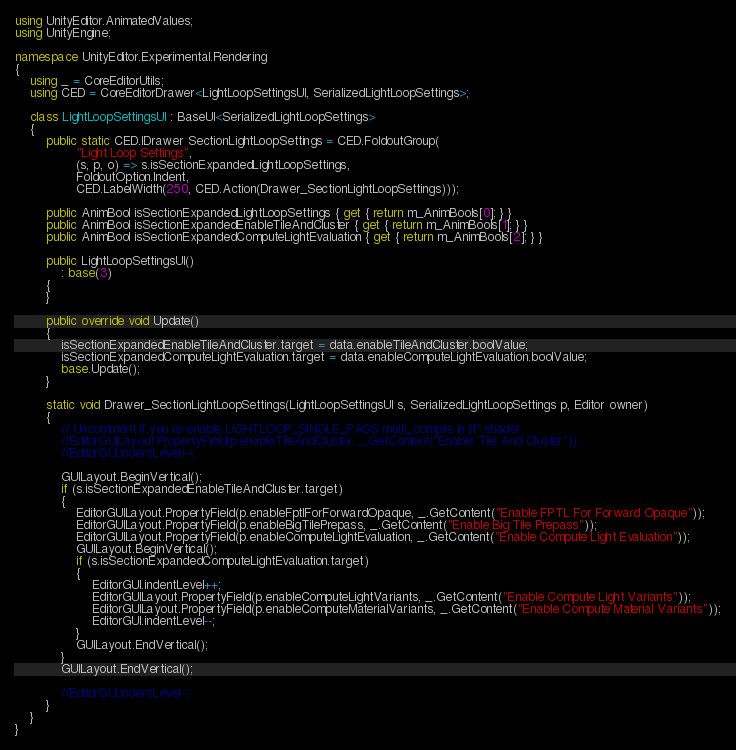Convert code to text. <code><loc_0><loc_0><loc_500><loc_500><_C#_>using UnityEditor.AnimatedValues;
using UnityEngine;

namespace UnityEditor.Experimental.Rendering
{
    using _ = CoreEditorUtils;
    using CED = CoreEditorDrawer<LightLoopSettingsUI, SerializedLightLoopSettings>;

    class LightLoopSettingsUI : BaseUI<SerializedLightLoopSettings>
    {
        public static CED.IDrawer SectionLightLoopSettings = CED.FoldoutGroup(
                "Light Loop Settings",
                (s, p, o) => s.isSectionExpandedLightLoopSettings,
                FoldoutOption.Indent,
                CED.LabelWidth(250, CED.Action(Drawer_SectionLightLoopSettings)));

        public AnimBool isSectionExpandedLightLoopSettings { get { return m_AnimBools[0]; } }
        public AnimBool isSectionExpandedEnableTileAndCluster { get { return m_AnimBools[1]; } }
        public AnimBool isSectionExpandedComputeLightEvaluation { get { return m_AnimBools[2]; } }

        public LightLoopSettingsUI()
            : base(3)
        {
        }

        public override void Update()
        {
            isSectionExpandedEnableTileAndCluster.target = data.enableTileAndCluster.boolValue;
            isSectionExpandedComputeLightEvaluation.target = data.enableComputeLightEvaluation.boolValue;
            base.Update();
        }

        static void Drawer_SectionLightLoopSettings(LightLoopSettingsUI s, SerializedLightLoopSettings p, Editor owner)
        {
            // Uncomment if you re-enable LIGHTLOOP_SINGLE_PASS multi_compile in lit*.shader
            //EditorGUILayout.PropertyField(p.enableTileAndCluster, _.GetContent("Enable Tile And Cluster"));
            //EditorGUI.indentLevel++;

            GUILayout.BeginVertical();
            if (s.isSectionExpandedEnableTileAndCluster.target)
            {
                EditorGUILayout.PropertyField(p.enableFptlForForwardOpaque, _.GetContent("Enable FPTL For Forward Opaque"));
                EditorGUILayout.PropertyField(p.enableBigTilePrepass, _.GetContent("Enable Big Tile Prepass"));
                EditorGUILayout.PropertyField(p.enableComputeLightEvaluation, _.GetContent("Enable Compute Light Evaluation"));
                GUILayout.BeginVertical();
                if (s.isSectionExpandedComputeLightEvaluation.target)
                {
                    EditorGUI.indentLevel++;
                    EditorGUILayout.PropertyField(p.enableComputeLightVariants, _.GetContent("Enable Compute Light Variants"));
                    EditorGUILayout.PropertyField(p.enableComputeMaterialVariants, _.GetContent("Enable Compute Material Variants"));
                    EditorGUI.indentLevel--;
                }
                GUILayout.EndVertical();
            }
            GUILayout.EndVertical();

            //EditorGUI.indentLevel--;
        }
    }
}
</code> 